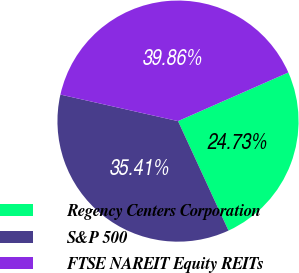<chart> <loc_0><loc_0><loc_500><loc_500><pie_chart><fcel>Regency Centers Corporation<fcel>S&P 500<fcel>FTSE NAREIT Equity REITs<nl><fcel>24.73%<fcel>35.41%<fcel>39.86%<nl></chart> 